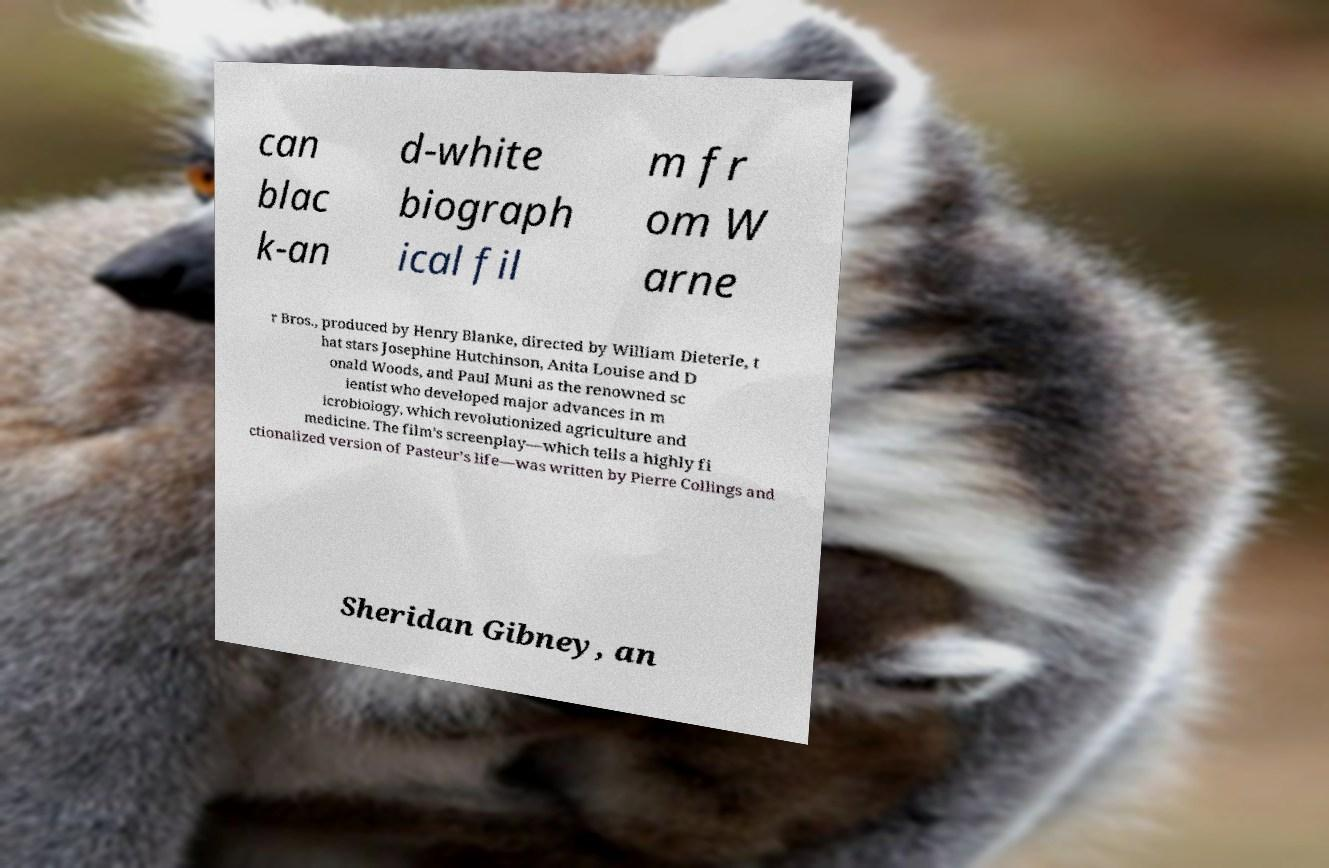For documentation purposes, I need the text within this image transcribed. Could you provide that? can blac k-an d-white biograph ical fil m fr om W arne r Bros., produced by Henry Blanke, directed by William Dieterle, t hat stars Josephine Hutchinson, Anita Louise and D onald Woods, and Paul Muni as the renowned sc ientist who developed major advances in m icrobiology, which revolutionized agriculture and medicine. The film's screenplay—which tells a highly fi ctionalized version of Pasteur’s life—was written by Pierre Collings and Sheridan Gibney, an 